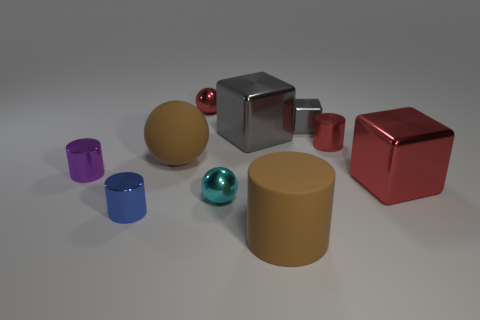Subtract all green cylinders. Subtract all gray blocks. How many cylinders are left? 4 Subtract all cylinders. How many objects are left? 6 Add 6 cylinders. How many cylinders exist? 10 Subtract 1 red cylinders. How many objects are left? 9 Subtract all small yellow shiny balls. Subtract all red shiny cylinders. How many objects are left? 9 Add 1 brown matte balls. How many brown matte balls are left? 2 